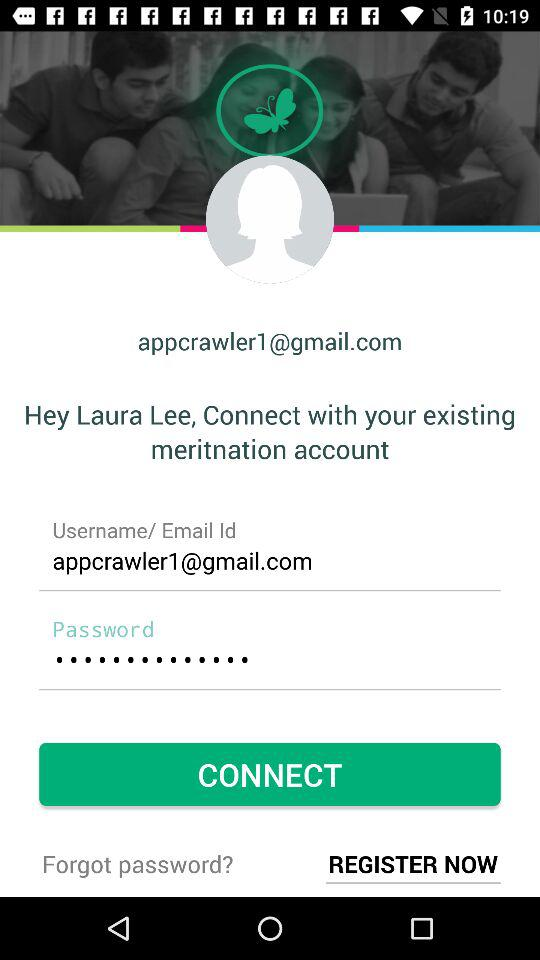How many characters are required to create a password?
When the provided information is insufficient, respond with <no answer>. <no answer> 